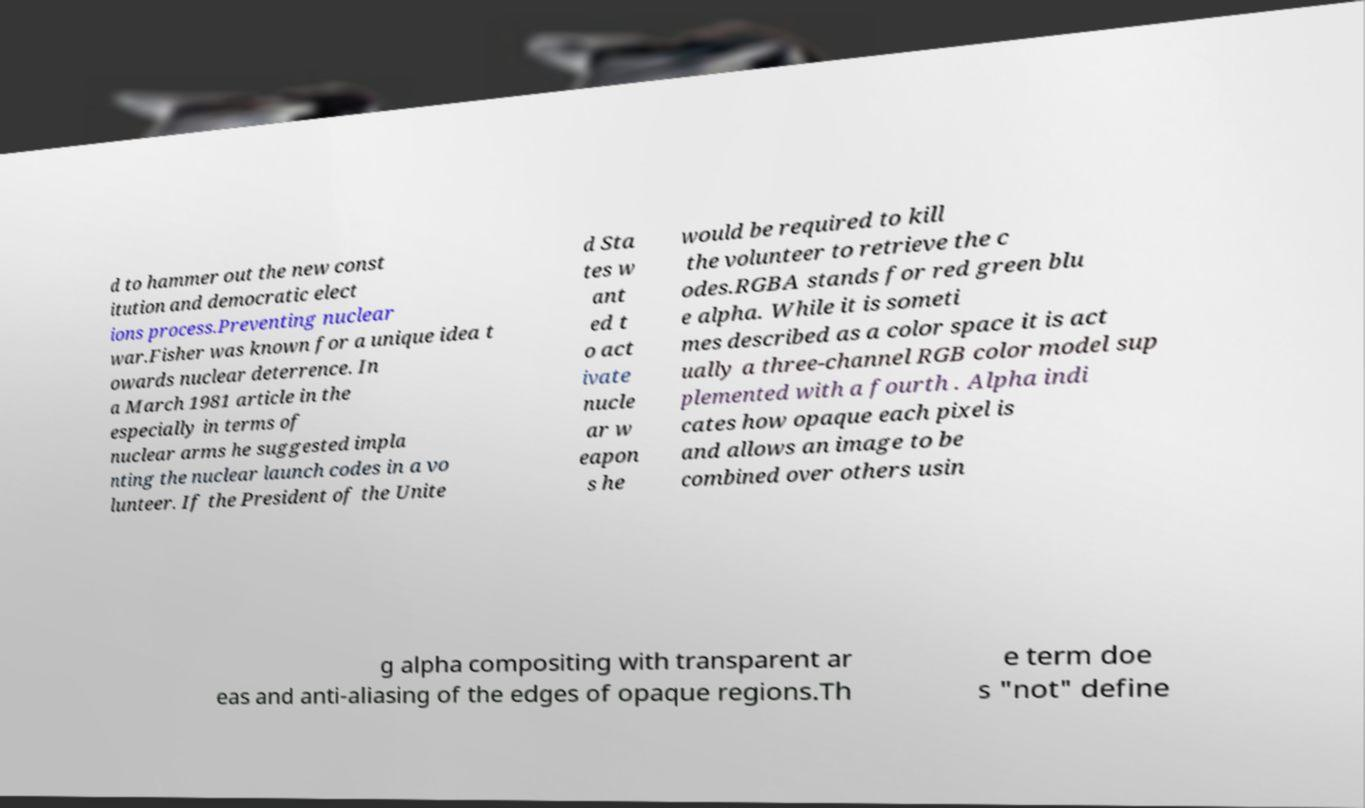For documentation purposes, I need the text within this image transcribed. Could you provide that? d to hammer out the new const itution and democratic elect ions process.Preventing nuclear war.Fisher was known for a unique idea t owards nuclear deterrence. In a March 1981 article in the especially in terms of nuclear arms he suggested impla nting the nuclear launch codes in a vo lunteer. If the President of the Unite d Sta tes w ant ed t o act ivate nucle ar w eapon s he would be required to kill the volunteer to retrieve the c odes.RGBA stands for red green blu e alpha. While it is someti mes described as a color space it is act ually a three-channel RGB color model sup plemented with a fourth . Alpha indi cates how opaque each pixel is and allows an image to be combined over others usin g alpha compositing with transparent ar eas and anti-aliasing of the edges of opaque regions.Th e term doe s "not" define 